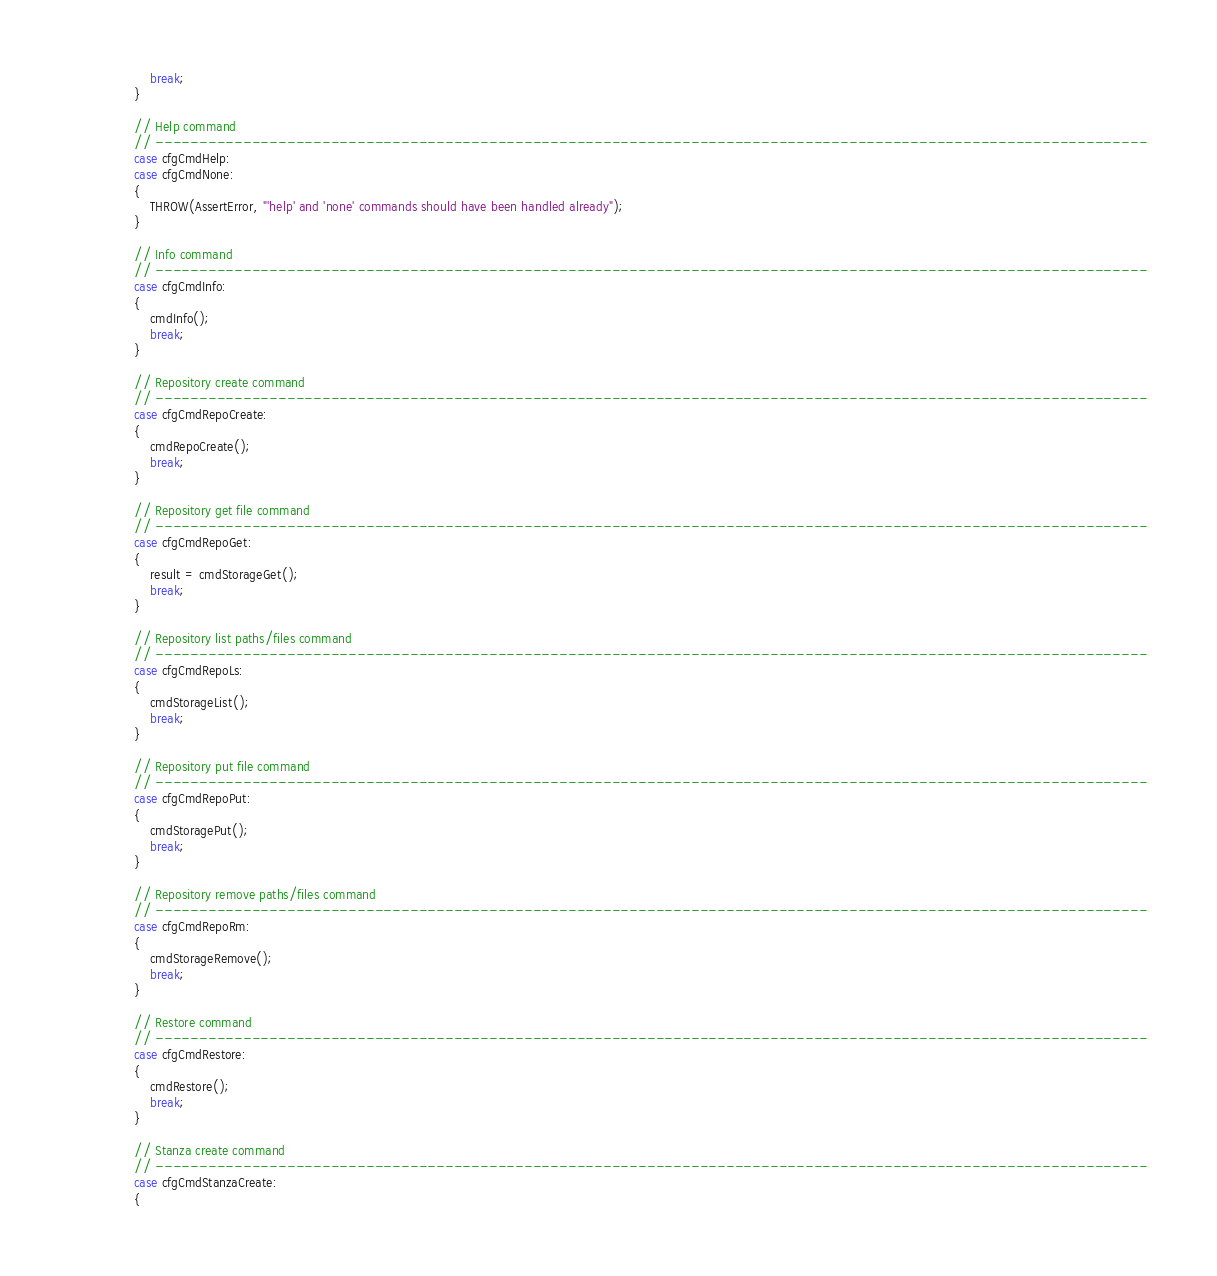<code> <loc_0><loc_0><loc_500><loc_500><_C_>                    break;
                }

                // Help command
                // -----------------------------------------------------------------------------------------------------------------
                case cfgCmdHelp:
                case cfgCmdNone:
                {
                    THROW(AssertError, "'help' and 'none' commands should have been handled already");
                }

                // Info command
                // -----------------------------------------------------------------------------------------------------------------
                case cfgCmdInfo:
                {
                    cmdInfo();
                    break;
                }

                // Repository create command
                // -----------------------------------------------------------------------------------------------------------------
                case cfgCmdRepoCreate:
                {
                    cmdRepoCreate();
                    break;
                }

                // Repository get file command
                // -----------------------------------------------------------------------------------------------------------------
                case cfgCmdRepoGet:
                {
                    result = cmdStorageGet();
                    break;
                }

                // Repository list paths/files command
                // -----------------------------------------------------------------------------------------------------------------
                case cfgCmdRepoLs:
                {
                    cmdStorageList();
                    break;
                }

                // Repository put file command
                // -----------------------------------------------------------------------------------------------------------------
                case cfgCmdRepoPut:
                {
                    cmdStoragePut();
                    break;
                }

                // Repository remove paths/files command
                // -----------------------------------------------------------------------------------------------------------------
                case cfgCmdRepoRm:
                {
                    cmdStorageRemove();
                    break;
                }

                // Restore command
                // -----------------------------------------------------------------------------------------------------------------
                case cfgCmdRestore:
                {
                    cmdRestore();
                    break;
                }

                // Stanza create command
                // -----------------------------------------------------------------------------------------------------------------
                case cfgCmdStanzaCreate:
                {</code> 